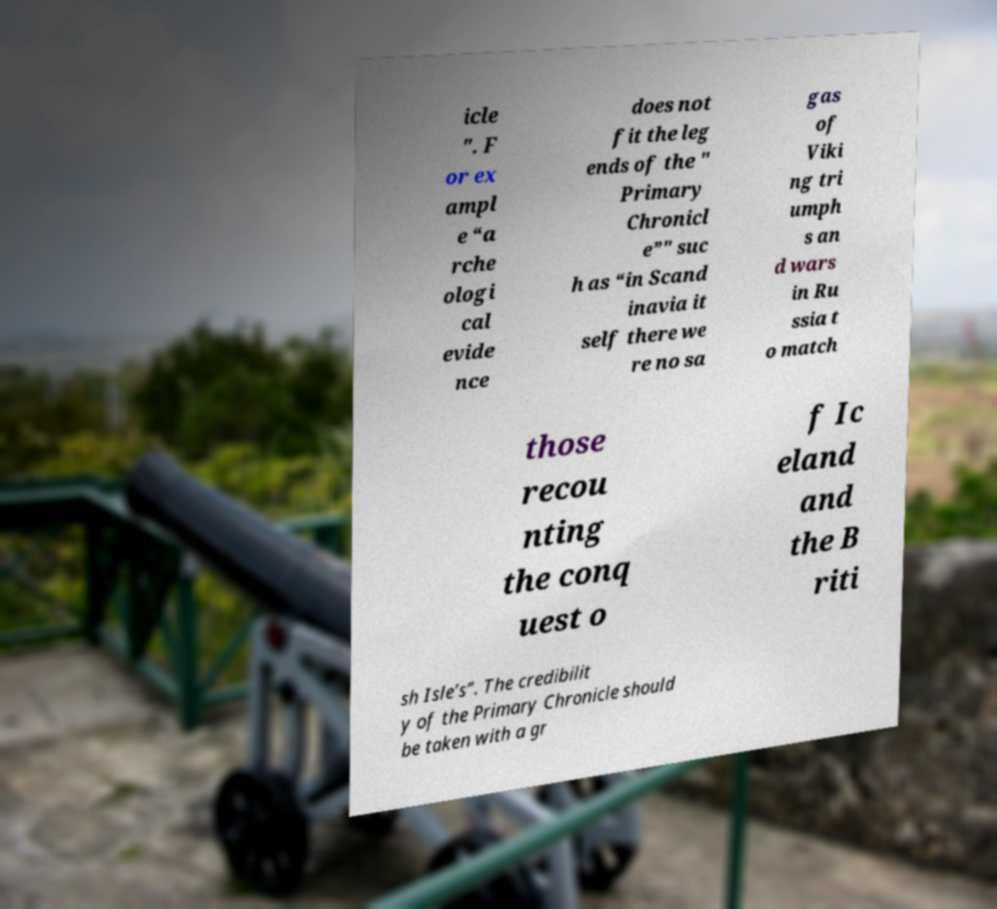Please identify and transcribe the text found in this image. icle ". F or ex ampl e “a rche ologi cal evide nce does not fit the leg ends of the " Primary Chronicl e”" suc h as “in Scand inavia it self there we re no sa gas of Viki ng tri umph s an d wars in Ru ssia t o match those recou nting the conq uest o f Ic eland and the B riti sh Isle’s”. The credibilit y of the Primary Chronicle should be taken with a gr 